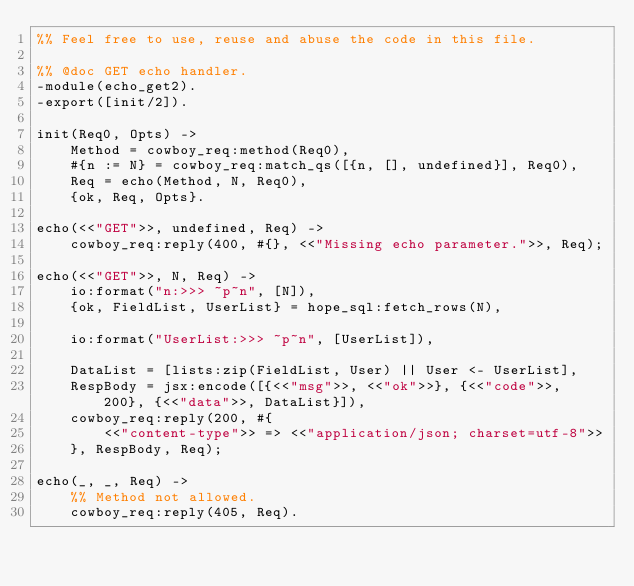Convert code to text. <code><loc_0><loc_0><loc_500><loc_500><_Erlang_>%% Feel free to use, reuse and abuse the code in this file.

%% @doc GET echo handler.
-module(echo_get2).
-export([init/2]).

init(Req0, Opts) ->
	Method = cowboy_req:method(Req0),
	#{n := N} = cowboy_req:match_qs([{n, [], undefined}], Req0),
	Req = echo(Method, N, Req0),
	{ok, Req, Opts}.

echo(<<"GET">>, undefined, Req) ->
	cowboy_req:reply(400, #{}, <<"Missing echo parameter.">>, Req);

echo(<<"GET">>, N, Req) ->
	io:format("n:>>> ~p~n", [N]),
	{ok, FieldList, UserList} = hope_sql:fetch_rows(N),

	io:format("UserList:>>> ~p~n", [UserList]),

	DataList = [lists:zip(FieldList, User) || User <- UserList],
	RespBody = jsx:encode([{<<"msg">>, <<"ok">>}, {<<"code">>, 200}, {<<"data">>, DataList}]),
	cowboy_req:reply(200, #{
		<<"content-type">> => <<"application/json; charset=utf-8">>
	}, RespBody, Req);

echo(_, _, Req) ->
	%% Method not allowed.
	cowboy_req:reply(405, Req).</code> 